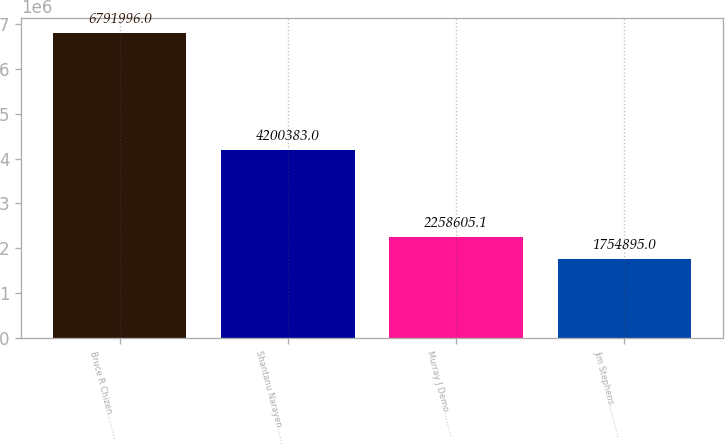Convert chart. <chart><loc_0><loc_0><loc_500><loc_500><bar_chart><fcel>Bruce R Chizen………<fcel>Shantanu Narayen……<fcel>Murray J Demo………<fcel>Jim Stephens…………<nl><fcel>6.792e+06<fcel>4.20038e+06<fcel>2.25861e+06<fcel>1.7549e+06<nl></chart> 